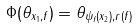Convert formula to latex. <formula><loc_0><loc_0><loc_500><loc_500>\Phi ( \theta _ { x _ { 1 } , f } ) = \theta _ { \psi _ { f } ( x _ { 2 } ) , r ( f ) }</formula> 